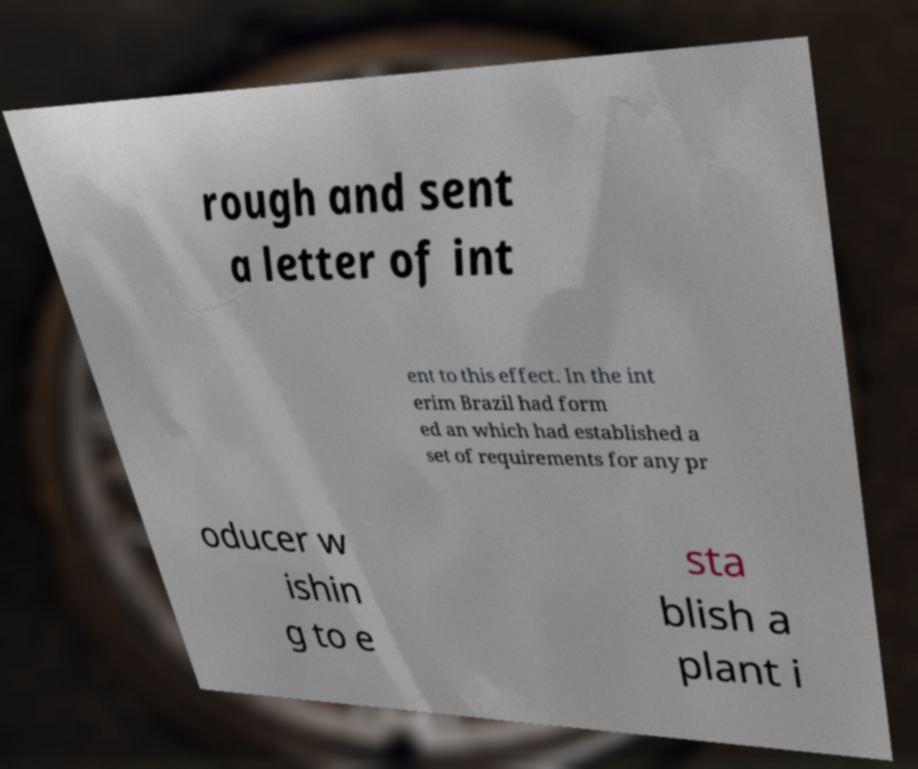Please identify and transcribe the text found in this image. rough and sent a letter of int ent to this effect. In the int erim Brazil had form ed an which had established a set of requirements for any pr oducer w ishin g to e sta blish a plant i 